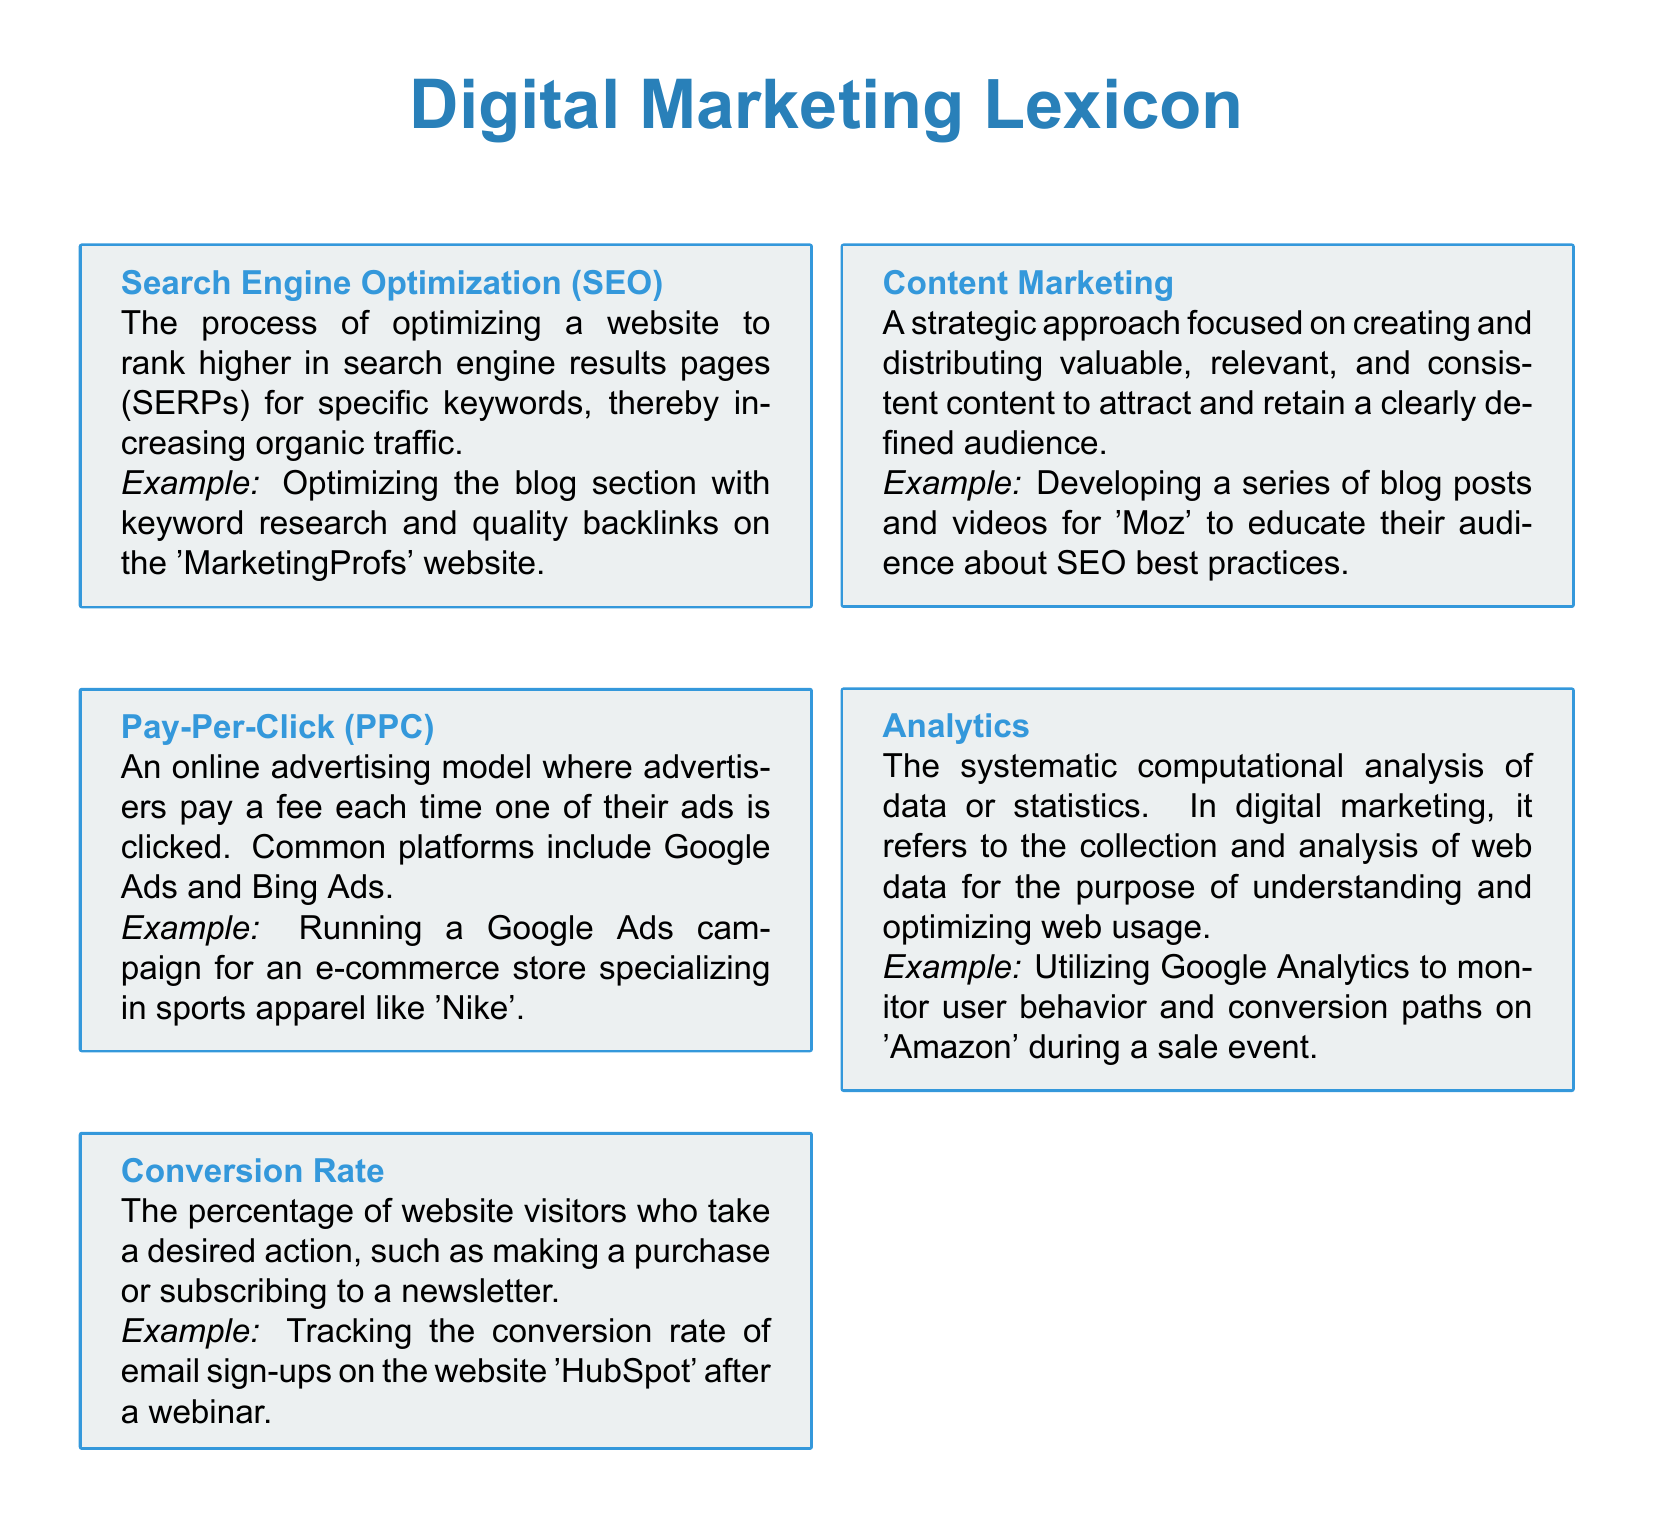What does SEO stand for? SEO is an abbreviation for Search Engine Optimization, as defined in the document.
Answer: Search Engine Optimization What is the example given for PPC? The document states the example of running a Google Ads campaign for an e-commerce store specializing in sports apparel.
Answer: Google Ads campaign for an e-commerce store What percentage does the conversion rate represent? The conversion rate represents the percentage of website visitors who take a desired action, as per the document.
Answer: Percentage of website visitors What is the primary focus of content marketing? Content marketing is primarily focused on creating and distributing valuable and relevant content to attract and retain an audience.
Answer: Creating and distributing valuable content Which tool is mentioned for analyzing web data? The document mentions Google Analytics as a tool for analyzing web data.
Answer: Google Analytics What type of marketing does the document relate to? The document relates to digital marketing, as expressed in the title.
Answer: Digital marketing How many terms are defined in the document? The document contains five distinct terms related to digital marketing.
Answer: Five terms What color is used for the term headings? The term headings are presented in a color defined as termcolor in the document.
Answer: termcolor 